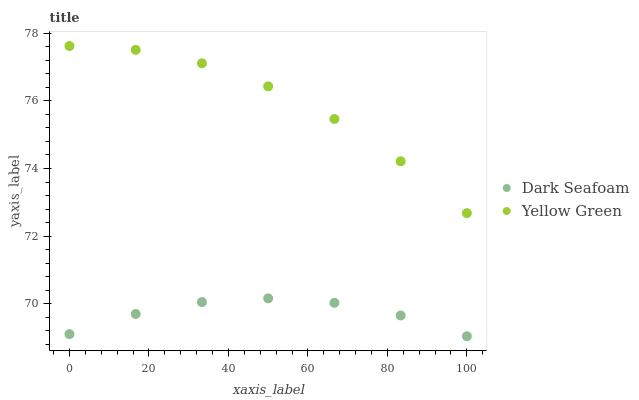Does Dark Seafoam have the minimum area under the curve?
Answer yes or no. Yes. Does Yellow Green have the maximum area under the curve?
Answer yes or no. Yes. Does Yellow Green have the minimum area under the curve?
Answer yes or no. No. Is Dark Seafoam the smoothest?
Answer yes or no. Yes. Is Yellow Green the roughest?
Answer yes or no. Yes. Is Yellow Green the smoothest?
Answer yes or no. No. Does Dark Seafoam have the lowest value?
Answer yes or no. Yes. Does Yellow Green have the lowest value?
Answer yes or no. No. Does Yellow Green have the highest value?
Answer yes or no. Yes. Is Dark Seafoam less than Yellow Green?
Answer yes or no. Yes. Is Yellow Green greater than Dark Seafoam?
Answer yes or no. Yes. Does Dark Seafoam intersect Yellow Green?
Answer yes or no. No. 